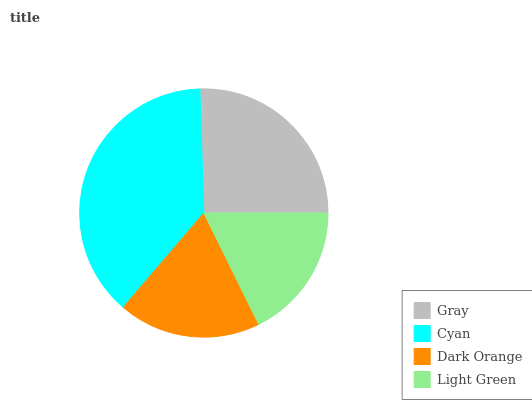Is Light Green the minimum?
Answer yes or no. Yes. Is Cyan the maximum?
Answer yes or no. Yes. Is Dark Orange the minimum?
Answer yes or no. No. Is Dark Orange the maximum?
Answer yes or no. No. Is Cyan greater than Dark Orange?
Answer yes or no. Yes. Is Dark Orange less than Cyan?
Answer yes or no. Yes. Is Dark Orange greater than Cyan?
Answer yes or no. No. Is Cyan less than Dark Orange?
Answer yes or no. No. Is Gray the high median?
Answer yes or no. Yes. Is Dark Orange the low median?
Answer yes or no. Yes. Is Dark Orange the high median?
Answer yes or no. No. Is Cyan the low median?
Answer yes or no. No. 